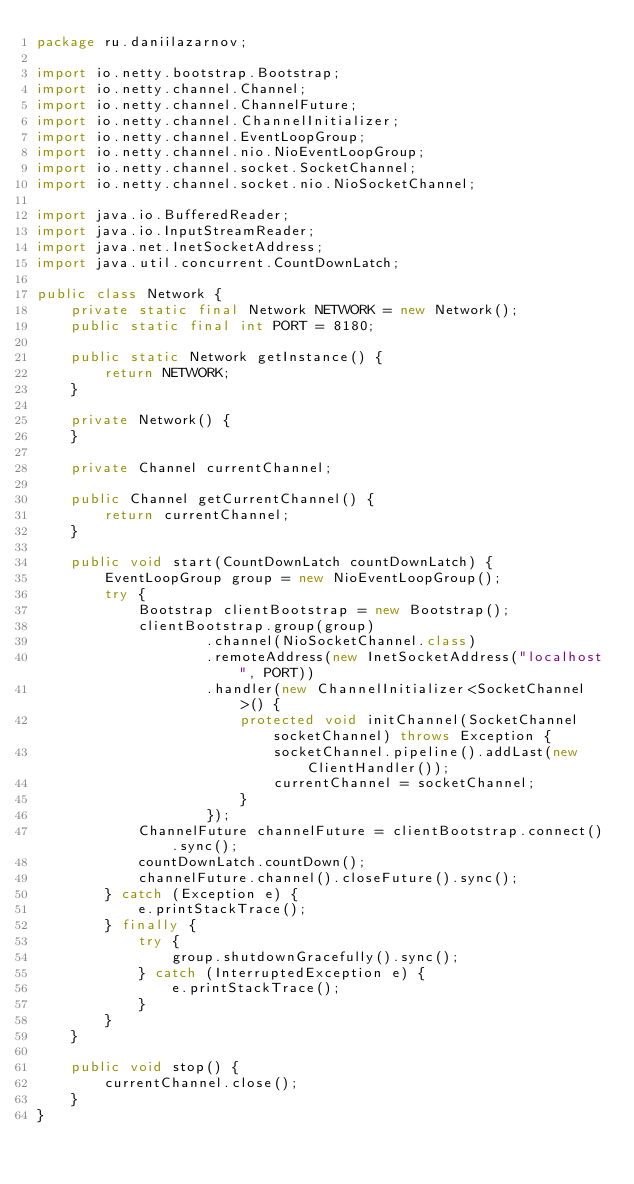<code> <loc_0><loc_0><loc_500><loc_500><_Java_>package ru.daniilazarnov;

import io.netty.bootstrap.Bootstrap;
import io.netty.channel.Channel;
import io.netty.channel.ChannelFuture;
import io.netty.channel.ChannelInitializer;
import io.netty.channel.EventLoopGroup;
import io.netty.channel.nio.NioEventLoopGroup;
import io.netty.channel.socket.SocketChannel;
import io.netty.channel.socket.nio.NioSocketChannel;

import java.io.BufferedReader;
import java.io.InputStreamReader;
import java.net.InetSocketAddress;
import java.util.concurrent.CountDownLatch;

public class Network {
    private static final Network NETWORK = new Network();
    public static final int PORT = 8180;

    public static Network getInstance() {
        return NETWORK;
    }

    private Network() {
    }

    private Channel currentChannel;

    public Channel getCurrentChannel() {
        return currentChannel;
    }

    public void start(CountDownLatch countDownLatch) {
        EventLoopGroup group = new NioEventLoopGroup();
        try {
            Bootstrap clientBootstrap = new Bootstrap();
            clientBootstrap.group(group)
                    .channel(NioSocketChannel.class)
                    .remoteAddress(new InetSocketAddress("localhost", PORT))
                    .handler(new ChannelInitializer<SocketChannel>() {
                        protected void initChannel(SocketChannel socketChannel) throws Exception {
                            socketChannel.pipeline().addLast(new ClientHandler());
                            currentChannel = socketChannel;
                        }
                    });
            ChannelFuture channelFuture = clientBootstrap.connect().sync();
            countDownLatch.countDown();
            channelFuture.channel().closeFuture().sync();
        } catch (Exception e) {
            e.printStackTrace();
        } finally {
            try {
                group.shutdownGracefully().sync();
            } catch (InterruptedException e) {
                e.printStackTrace();
            }
        }
    }

    public void stop() {
        currentChannel.close();
    }
}
</code> 